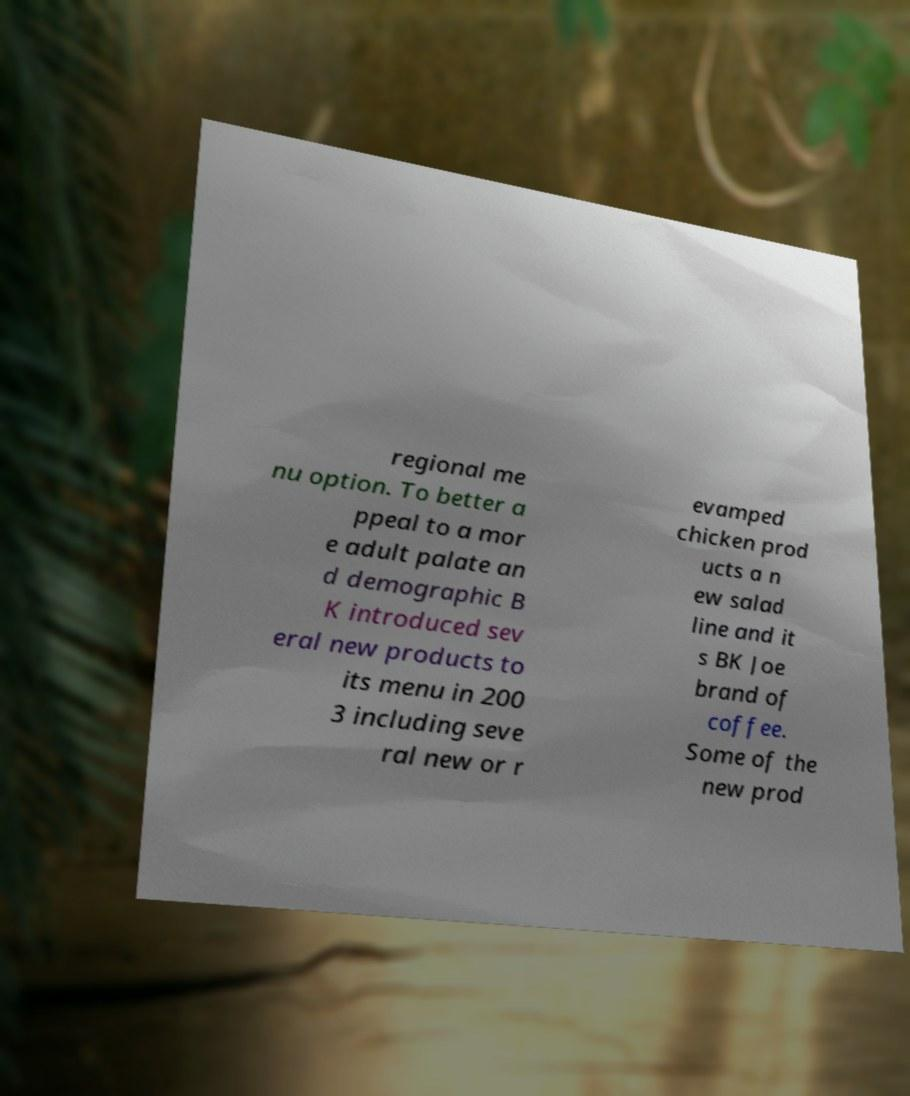What messages or text are displayed in this image? I need them in a readable, typed format. regional me nu option. To better a ppeal to a mor e adult palate an d demographic B K introduced sev eral new products to its menu in 200 3 including seve ral new or r evamped chicken prod ucts a n ew salad line and it s BK Joe brand of coffee. Some of the new prod 